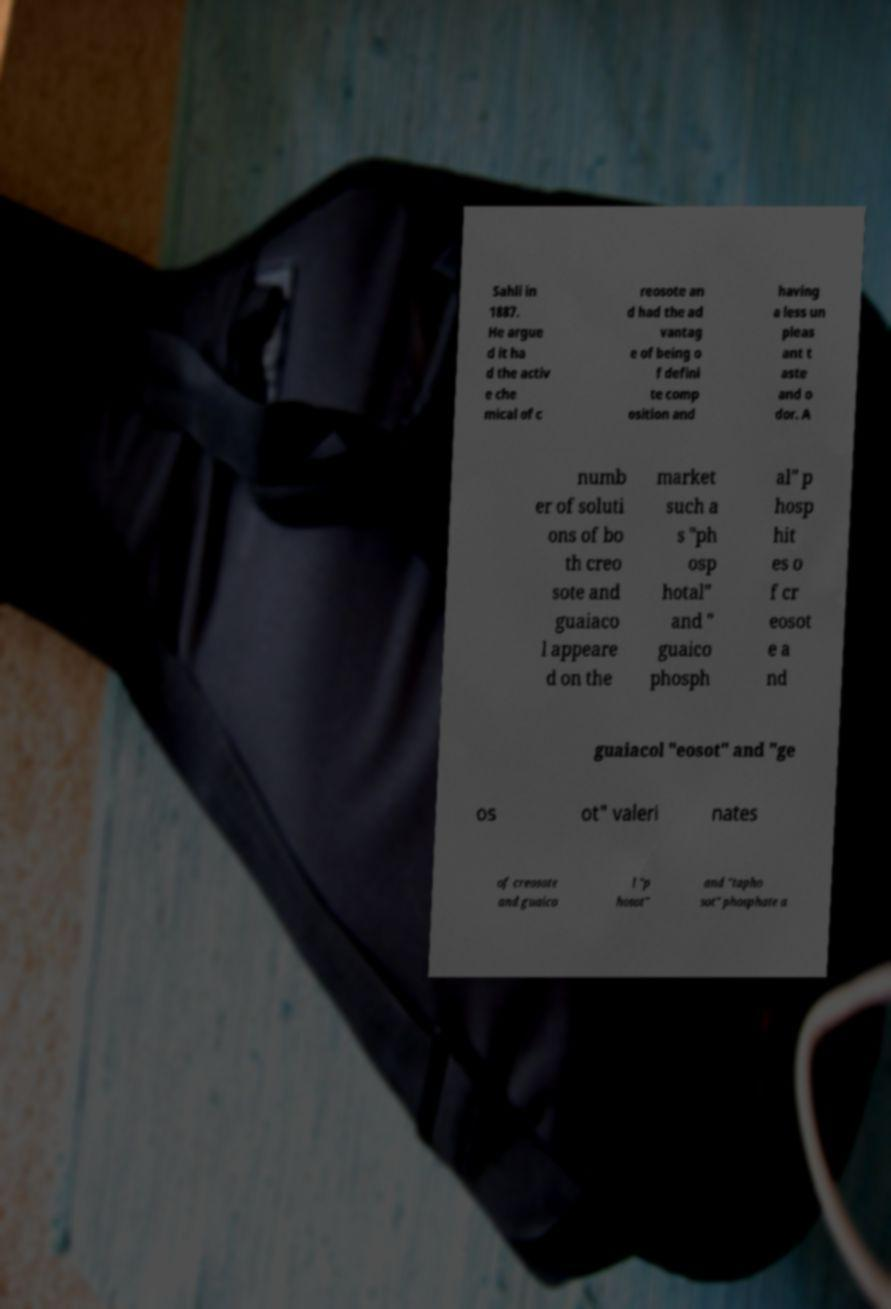Please read and relay the text visible in this image. What does it say? Sahli in 1887. He argue d it ha d the activ e che mical of c reosote an d had the ad vantag e of being o f defini te comp osition and having a less un pleas ant t aste and o dor. A numb er of soluti ons of bo th creo sote and guaiaco l appeare d on the market such a s "ph osp hotal" and " guaico phosph al" p hosp hit es o f cr eosot e a nd guaiacol "eosot" and "ge os ot" valeri nates of creosote and guaico l "p hosot" and "tapho sot" phosphate a 